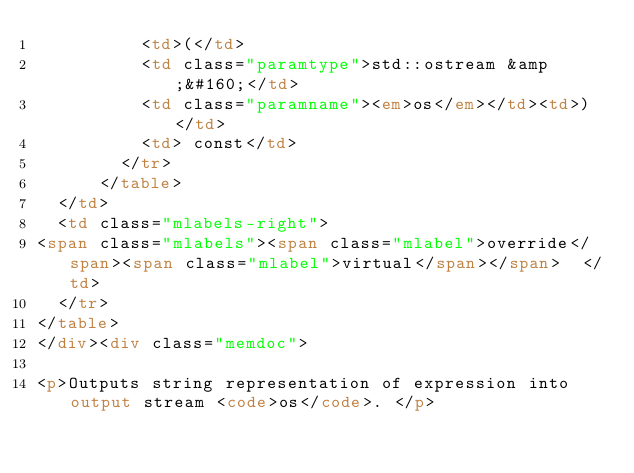<code> <loc_0><loc_0><loc_500><loc_500><_HTML_>          <td>(</td>
          <td class="paramtype">std::ostream &amp;&#160;</td>
          <td class="paramname"><em>os</em></td><td>)</td>
          <td> const</td>
        </tr>
      </table>
  </td>
  <td class="mlabels-right">
<span class="mlabels"><span class="mlabel">override</span><span class="mlabel">virtual</span></span>  </td>
  </tr>
</table>
</div><div class="memdoc">

<p>Outputs string representation of expression into output stream <code>os</code>. </p>
</code> 